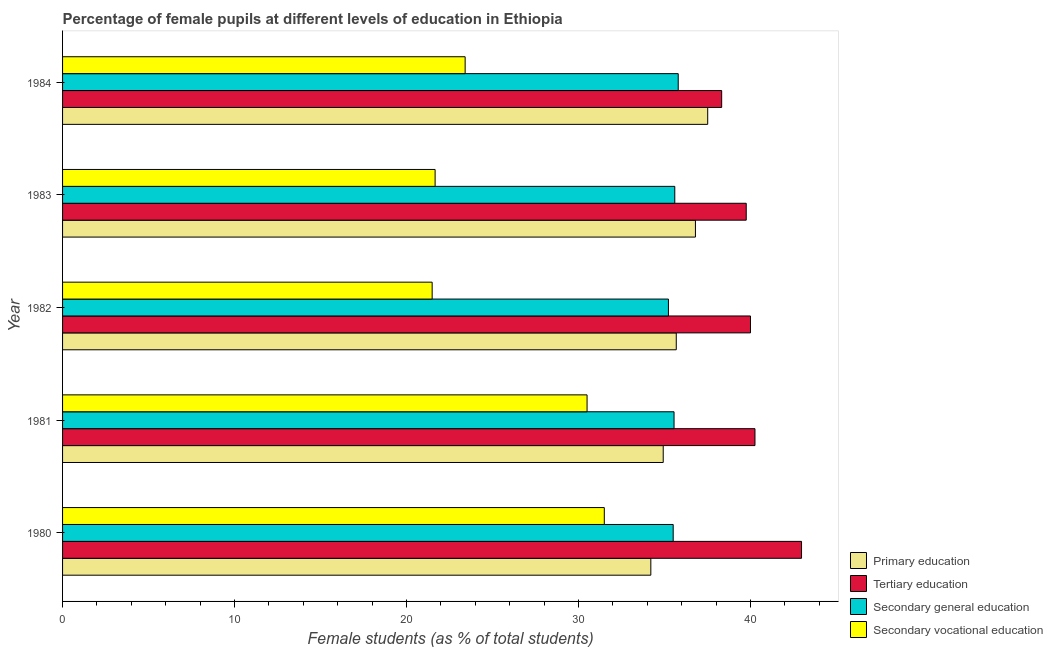How many different coloured bars are there?
Keep it short and to the point. 4. How many groups of bars are there?
Give a very brief answer. 5. Are the number of bars on each tick of the Y-axis equal?
Ensure brevity in your answer.  Yes. How many bars are there on the 5th tick from the top?
Offer a terse response. 4. In how many cases, is the number of bars for a given year not equal to the number of legend labels?
Give a very brief answer. 0. What is the percentage of female students in tertiary education in 1983?
Provide a short and direct response. 39.75. Across all years, what is the maximum percentage of female students in tertiary education?
Give a very brief answer. 42.96. Across all years, what is the minimum percentage of female students in secondary education?
Ensure brevity in your answer.  35.22. In which year was the percentage of female students in secondary vocational education maximum?
Keep it short and to the point. 1980. What is the total percentage of female students in secondary vocational education in the graph?
Offer a terse response. 128.54. What is the difference between the percentage of female students in secondary vocational education in 1982 and that in 1983?
Provide a short and direct response. -0.17. What is the difference between the percentage of female students in primary education in 1982 and the percentage of female students in secondary education in 1980?
Make the answer very short. 0.18. What is the average percentage of female students in primary education per year?
Keep it short and to the point. 35.82. In the year 1984, what is the difference between the percentage of female students in primary education and percentage of female students in tertiary education?
Make the answer very short. -0.81. In how many years, is the percentage of female students in secondary vocational education greater than 32 %?
Your answer should be very brief. 0. What is the ratio of the percentage of female students in tertiary education in 1982 to that in 1984?
Give a very brief answer. 1.04. Is the percentage of female students in tertiary education in 1981 less than that in 1982?
Your response must be concise. No. Is the difference between the percentage of female students in secondary education in 1982 and 1983 greater than the difference between the percentage of female students in tertiary education in 1982 and 1983?
Your answer should be compact. No. What is the difference between the highest and the lowest percentage of female students in secondary education?
Your response must be concise. 0.57. In how many years, is the percentage of female students in secondary education greater than the average percentage of female students in secondary education taken over all years?
Your answer should be very brief. 3. Is it the case that in every year, the sum of the percentage of female students in primary education and percentage of female students in secondary education is greater than the sum of percentage of female students in tertiary education and percentage of female students in secondary vocational education?
Ensure brevity in your answer.  No. What does the 3rd bar from the top in 1984 represents?
Your response must be concise. Tertiary education. Is it the case that in every year, the sum of the percentage of female students in primary education and percentage of female students in tertiary education is greater than the percentage of female students in secondary education?
Your response must be concise. Yes. How many bars are there?
Offer a terse response. 20. What is the difference between two consecutive major ticks on the X-axis?
Offer a very short reply. 10. Are the values on the major ticks of X-axis written in scientific E-notation?
Offer a very short reply. No. Where does the legend appear in the graph?
Your response must be concise. Bottom right. How many legend labels are there?
Your answer should be compact. 4. What is the title of the graph?
Give a very brief answer. Percentage of female pupils at different levels of education in Ethiopia. Does "United Kingdom" appear as one of the legend labels in the graph?
Provide a short and direct response. No. What is the label or title of the X-axis?
Your answer should be very brief. Female students (as % of total students). What is the Female students (as % of total students) in Primary education in 1980?
Keep it short and to the point. 34.2. What is the Female students (as % of total students) in Tertiary education in 1980?
Provide a succinct answer. 42.96. What is the Female students (as % of total students) of Secondary general education in 1980?
Make the answer very short. 35.5. What is the Female students (as % of total students) in Secondary vocational education in 1980?
Provide a short and direct response. 31.5. What is the Female students (as % of total students) in Primary education in 1981?
Provide a succinct answer. 34.92. What is the Female students (as % of total students) of Tertiary education in 1981?
Give a very brief answer. 40.25. What is the Female students (as % of total students) of Secondary general education in 1981?
Your answer should be compact. 35.55. What is the Female students (as % of total students) in Secondary vocational education in 1981?
Make the answer very short. 30.49. What is the Female students (as % of total students) in Primary education in 1982?
Provide a succinct answer. 35.68. What is the Female students (as % of total students) of Tertiary education in 1982?
Your answer should be compact. 40. What is the Female students (as % of total students) of Secondary general education in 1982?
Your response must be concise. 35.22. What is the Female students (as % of total students) in Secondary vocational education in 1982?
Your response must be concise. 21.49. What is the Female students (as % of total students) in Primary education in 1983?
Your answer should be compact. 36.79. What is the Female students (as % of total students) of Tertiary education in 1983?
Make the answer very short. 39.75. What is the Female students (as % of total students) of Secondary general education in 1983?
Make the answer very short. 35.59. What is the Female students (as % of total students) of Secondary vocational education in 1983?
Make the answer very short. 21.66. What is the Female students (as % of total students) of Primary education in 1984?
Your response must be concise. 37.51. What is the Female students (as % of total students) of Tertiary education in 1984?
Keep it short and to the point. 38.32. What is the Female students (as % of total students) of Secondary general education in 1984?
Your answer should be very brief. 35.79. What is the Female students (as % of total students) of Secondary vocational education in 1984?
Keep it short and to the point. 23.41. Across all years, what is the maximum Female students (as % of total students) of Primary education?
Your answer should be very brief. 37.51. Across all years, what is the maximum Female students (as % of total students) of Tertiary education?
Keep it short and to the point. 42.96. Across all years, what is the maximum Female students (as % of total students) in Secondary general education?
Offer a terse response. 35.79. Across all years, what is the maximum Female students (as % of total students) of Secondary vocational education?
Offer a terse response. 31.5. Across all years, what is the minimum Female students (as % of total students) in Primary education?
Make the answer very short. 34.2. Across all years, what is the minimum Female students (as % of total students) in Tertiary education?
Your answer should be very brief. 38.32. Across all years, what is the minimum Female students (as % of total students) of Secondary general education?
Ensure brevity in your answer.  35.22. Across all years, what is the minimum Female students (as % of total students) of Secondary vocational education?
Provide a succinct answer. 21.49. What is the total Female students (as % of total students) in Primary education in the graph?
Provide a succinct answer. 179.1. What is the total Female students (as % of total students) in Tertiary education in the graph?
Provide a succinct answer. 201.28. What is the total Female students (as % of total students) in Secondary general education in the graph?
Offer a terse response. 177.66. What is the total Female students (as % of total students) in Secondary vocational education in the graph?
Offer a very short reply. 128.54. What is the difference between the Female students (as % of total students) in Primary education in 1980 and that in 1981?
Provide a short and direct response. -0.72. What is the difference between the Female students (as % of total students) of Tertiary education in 1980 and that in 1981?
Give a very brief answer. 2.71. What is the difference between the Female students (as % of total students) of Secondary general education in 1980 and that in 1981?
Provide a short and direct response. -0.05. What is the difference between the Female students (as % of total students) in Primary education in 1980 and that in 1982?
Offer a very short reply. -1.48. What is the difference between the Female students (as % of total students) in Tertiary education in 1980 and that in 1982?
Offer a very short reply. 2.97. What is the difference between the Female students (as % of total students) in Secondary general education in 1980 and that in 1982?
Your answer should be compact. 0.28. What is the difference between the Female students (as % of total students) in Secondary vocational education in 1980 and that in 1982?
Keep it short and to the point. 10.01. What is the difference between the Female students (as % of total students) of Primary education in 1980 and that in 1983?
Ensure brevity in your answer.  -2.59. What is the difference between the Female students (as % of total students) of Tertiary education in 1980 and that in 1983?
Your response must be concise. 3.21. What is the difference between the Female students (as % of total students) in Secondary general education in 1980 and that in 1983?
Offer a terse response. -0.09. What is the difference between the Female students (as % of total students) in Secondary vocational education in 1980 and that in 1983?
Provide a short and direct response. 9.84. What is the difference between the Female students (as % of total students) of Primary education in 1980 and that in 1984?
Your response must be concise. -3.31. What is the difference between the Female students (as % of total students) in Tertiary education in 1980 and that in 1984?
Your answer should be very brief. 4.64. What is the difference between the Female students (as % of total students) of Secondary general education in 1980 and that in 1984?
Make the answer very short. -0.29. What is the difference between the Female students (as % of total students) in Secondary vocational education in 1980 and that in 1984?
Ensure brevity in your answer.  8.09. What is the difference between the Female students (as % of total students) in Primary education in 1981 and that in 1982?
Keep it short and to the point. -0.76. What is the difference between the Female students (as % of total students) of Tertiary education in 1981 and that in 1982?
Your answer should be compact. 0.26. What is the difference between the Female students (as % of total students) in Secondary general education in 1981 and that in 1982?
Make the answer very short. 0.33. What is the difference between the Female students (as % of total students) in Secondary vocational education in 1981 and that in 1982?
Keep it short and to the point. 9.01. What is the difference between the Female students (as % of total students) of Primary education in 1981 and that in 1983?
Give a very brief answer. -1.87. What is the difference between the Female students (as % of total students) of Tertiary education in 1981 and that in 1983?
Give a very brief answer. 0.51. What is the difference between the Female students (as % of total students) of Secondary general education in 1981 and that in 1983?
Ensure brevity in your answer.  -0.04. What is the difference between the Female students (as % of total students) of Secondary vocational education in 1981 and that in 1983?
Offer a very short reply. 8.83. What is the difference between the Female students (as % of total students) in Primary education in 1981 and that in 1984?
Keep it short and to the point. -2.59. What is the difference between the Female students (as % of total students) in Tertiary education in 1981 and that in 1984?
Keep it short and to the point. 1.94. What is the difference between the Female students (as % of total students) of Secondary general education in 1981 and that in 1984?
Offer a very short reply. -0.24. What is the difference between the Female students (as % of total students) in Secondary vocational education in 1981 and that in 1984?
Your answer should be compact. 7.09. What is the difference between the Female students (as % of total students) of Primary education in 1982 and that in 1983?
Offer a very short reply. -1.11. What is the difference between the Female students (as % of total students) of Tertiary education in 1982 and that in 1983?
Ensure brevity in your answer.  0.25. What is the difference between the Female students (as % of total students) in Secondary general education in 1982 and that in 1983?
Offer a very short reply. -0.37. What is the difference between the Female students (as % of total students) in Secondary vocational education in 1982 and that in 1983?
Keep it short and to the point. -0.17. What is the difference between the Female students (as % of total students) of Primary education in 1982 and that in 1984?
Offer a very short reply. -1.83. What is the difference between the Female students (as % of total students) in Tertiary education in 1982 and that in 1984?
Keep it short and to the point. 1.68. What is the difference between the Female students (as % of total students) in Secondary general education in 1982 and that in 1984?
Offer a very short reply. -0.57. What is the difference between the Female students (as % of total students) of Secondary vocational education in 1982 and that in 1984?
Provide a succinct answer. -1.92. What is the difference between the Female students (as % of total students) of Primary education in 1983 and that in 1984?
Provide a succinct answer. -0.71. What is the difference between the Female students (as % of total students) in Tertiary education in 1983 and that in 1984?
Offer a very short reply. 1.43. What is the difference between the Female students (as % of total students) in Secondary general education in 1983 and that in 1984?
Give a very brief answer. -0.2. What is the difference between the Female students (as % of total students) of Secondary vocational education in 1983 and that in 1984?
Provide a succinct answer. -1.75. What is the difference between the Female students (as % of total students) of Primary education in 1980 and the Female students (as % of total students) of Tertiary education in 1981?
Your answer should be compact. -6.05. What is the difference between the Female students (as % of total students) of Primary education in 1980 and the Female students (as % of total students) of Secondary general education in 1981?
Your answer should be compact. -1.35. What is the difference between the Female students (as % of total students) of Primary education in 1980 and the Female students (as % of total students) of Secondary vocational education in 1981?
Give a very brief answer. 3.71. What is the difference between the Female students (as % of total students) in Tertiary education in 1980 and the Female students (as % of total students) in Secondary general education in 1981?
Your response must be concise. 7.41. What is the difference between the Female students (as % of total students) in Tertiary education in 1980 and the Female students (as % of total students) in Secondary vocational education in 1981?
Your answer should be very brief. 12.47. What is the difference between the Female students (as % of total students) in Secondary general education in 1980 and the Female students (as % of total students) in Secondary vocational education in 1981?
Your response must be concise. 5.01. What is the difference between the Female students (as % of total students) in Primary education in 1980 and the Female students (as % of total students) in Tertiary education in 1982?
Ensure brevity in your answer.  -5.8. What is the difference between the Female students (as % of total students) in Primary education in 1980 and the Female students (as % of total students) in Secondary general education in 1982?
Give a very brief answer. -1.02. What is the difference between the Female students (as % of total students) in Primary education in 1980 and the Female students (as % of total students) in Secondary vocational education in 1982?
Keep it short and to the point. 12.71. What is the difference between the Female students (as % of total students) of Tertiary education in 1980 and the Female students (as % of total students) of Secondary general education in 1982?
Provide a short and direct response. 7.74. What is the difference between the Female students (as % of total students) in Tertiary education in 1980 and the Female students (as % of total students) in Secondary vocational education in 1982?
Your answer should be compact. 21.47. What is the difference between the Female students (as % of total students) in Secondary general education in 1980 and the Female students (as % of total students) in Secondary vocational education in 1982?
Ensure brevity in your answer.  14.01. What is the difference between the Female students (as % of total students) of Primary education in 1980 and the Female students (as % of total students) of Tertiary education in 1983?
Provide a short and direct response. -5.55. What is the difference between the Female students (as % of total students) in Primary education in 1980 and the Female students (as % of total students) in Secondary general education in 1983?
Make the answer very short. -1.39. What is the difference between the Female students (as % of total students) in Primary education in 1980 and the Female students (as % of total students) in Secondary vocational education in 1983?
Provide a short and direct response. 12.54. What is the difference between the Female students (as % of total students) in Tertiary education in 1980 and the Female students (as % of total students) in Secondary general education in 1983?
Give a very brief answer. 7.37. What is the difference between the Female students (as % of total students) of Tertiary education in 1980 and the Female students (as % of total students) of Secondary vocational education in 1983?
Your answer should be very brief. 21.3. What is the difference between the Female students (as % of total students) in Secondary general education in 1980 and the Female students (as % of total students) in Secondary vocational education in 1983?
Your answer should be compact. 13.84. What is the difference between the Female students (as % of total students) of Primary education in 1980 and the Female students (as % of total students) of Tertiary education in 1984?
Provide a succinct answer. -4.12. What is the difference between the Female students (as % of total students) in Primary education in 1980 and the Female students (as % of total students) in Secondary general education in 1984?
Your response must be concise. -1.59. What is the difference between the Female students (as % of total students) in Primary education in 1980 and the Female students (as % of total students) in Secondary vocational education in 1984?
Make the answer very short. 10.79. What is the difference between the Female students (as % of total students) in Tertiary education in 1980 and the Female students (as % of total students) in Secondary general education in 1984?
Give a very brief answer. 7.17. What is the difference between the Female students (as % of total students) in Tertiary education in 1980 and the Female students (as % of total students) in Secondary vocational education in 1984?
Provide a succinct answer. 19.56. What is the difference between the Female students (as % of total students) of Secondary general education in 1980 and the Female students (as % of total students) of Secondary vocational education in 1984?
Your answer should be compact. 12.1. What is the difference between the Female students (as % of total students) in Primary education in 1981 and the Female students (as % of total students) in Tertiary education in 1982?
Make the answer very short. -5.07. What is the difference between the Female students (as % of total students) of Primary education in 1981 and the Female students (as % of total students) of Secondary general education in 1982?
Provide a short and direct response. -0.3. What is the difference between the Female students (as % of total students) in Primary education in 1981 and the Female students (as % of total students) in Secondary vocational education in 1982?
Offer a terse response. 13.43. What is the difference between the Female students (as % of total students) of Tertiary education in 1981 and the Female students (as % of total students) of Secondary general education in 1982?
Your answer should be compact. 5.03. What is the difference between the Female students (as % of total students) in Tertiary education in 1981 and the Female students (as % of total students) in Secondary vocational education in 1982?
Keep it short and to the point. 18.77. What is the difference between the Female students (as % of total students) in Secondary general education in 1981 and the Female students (as % of total students) in Secondary vocational education in 1982?
Provide a succinct answer. 14.06. What is the difference between the Female students (as % of total students) of Primary education in 1981 and the Female students (as % of total students) of Tertiary education in 1983?
Give a very brief answer. -4.83. What is the difference between the Female students (as % of total students) of Primary education in 1981 and the Female students (as % of total students) of Secondary general education in 1983?
Your answer should be very brief. -0.67. What is the difference between the Female students (as % of total students) of Primary education in 1981 and the Female students (as % of total students) of Secondary vocational education in 1983?
Your response must be concise. 13.26. What is the difference between the Female students (as % of total students) of Tertiary education in 1981 and the Female students (as % of total students) of Secondary general education in 1983?
Your response must be concise. 4.66. What is the difference between the Female students (as % of total students) in Tertiary education in 1981 and the Female students (as % of total students) in Secondary vocational education in 1983?
Provide a succinct answer. 18.6. What is the difference between the Female students (as % of total students) in Secondary general education in 1981 and the Female students (as % of total students) in Secondary vocational education in 1983?
Keep it short and to the point. 13.89. What is the difference between the Female students (as % of total students) in Primary education in 1981 and the Female students (as % of total students) in Tertiary education in 1984?
Provide a short and direct response. -3.4. What is the difference between the Female students (as % of total students) in Primary education in 1981 and the Female students (as % of total students) in Secondary general education in 1984?
Your answer should be very brief. -0.87. What is the difference between the Female students (as % of total students) of Primary education in 1981 and the Female students (as % of total students) of Secondary vocational education in 1984?
Your answer should be very brief. 11.52. What is the difference between the Female students (as % of total students) of Tertiary education in 1981 and the Female students (as % of total students) of Secondary general education in 1984?
Your response must be concise. 4.46. What is the difference between the Female students (as % of total students) of Tertiary education in 1981 and the Female students (as % of total students) of Secondary vocational education in 1984?
Your answer should be compact. 16.85. What is the difference between the Female students (as % of total students) of Secondary general education in 1981 and the Female students (as % of total students) of Secondary vocational education in 1984?
Your response must be concise. 12.14. What is the difference between the Female students (as % of total students) in Primary education in 1982 and the Female students (as % of total students) in Tertiary education in 1983?
Make the answer very short. -4.07. What is the difference between the Female students (as % of total students) in Primary education in 1982 and the Female students (as % of total students) in Secondary general education in 1983?
Offer a terse response. 0.09. What is the difference between the Female students (as % of total students) in Primary education in 1982 and the Female students (as % of total students) in Secondary vocational education in 1983?
Offer a terse response. 14.02. What is the difference between the Female students (as % of total students) in Tertiary education in 1982 and the Female students (as % of total students) in Secondary general education in 1983?
Your answer should be compact. 4.4. What is the difference between the Female students (as % of total students) in Tertiary education in 1982 and the Female students (as % of total students) in Secondary vocational education in 1983?
Provide a short and direct response. 18.34. What is the difference between the Female students (as % of total students) in Secondary general education in 1982 and the Female students (as % of total students) in Secondary vocational education in 1983?
Keep it short and to the point. 13.57. What is the difference between the Female students (as % of total students) of Primary education in 1982 and the Female students (as % of total students) of Tertiary education in 1984?
Offer a terse response. -2.64. What is the difference between the Female students (as % of total students) of Primary education in 1982 and the Female students (as % of total students) of Secondary general education in 1984?
Your response must be concise. -0.11. What is the difference between the Female students (as % of total students) in Primary education in 1982 and the Female students (as % of total students) in Secondary vocational education in 1984?
Ensure brevity in your answer.  12.27. What is the difference between the Female students (as % of total students) in Tertiary education in 1982 and the Female students (as % of total students) in Secondary general education in 1984?
Your response must be concise. 4.2. What is the difference between the Female students (as % of total students) of Tertiary education in 1982 and the Female students (as % of total students) of Secondary vocational education in 1984?
Provide a short and direct response. 16.59. What is the difference between the Female students (as % of total students) of Secondary general education in 1982 and the Female students (as % of total students) of Secondary vocational education in 1984?
Ensure brevity in your answer.  11.82. What is the difference between the Female students (as % of total students) of Primary education in 1983 and the Female students (as % of total students) of Tertiary education in 1984?
Keep it short and to the point. -1.53. What is the difference between the Female students (as % of total students) of Primary education in 1983 and the Female students (as % of total students) of Secondary general education in 1984?
Provide a succinct answer. 1. What is the difference between the Female students (as % of total students) in Primary education in 1983 and the Female students (as % of total students) in Secondary vocational education in 1984?
Keep it short and to the point. 13.39. What is the difference between the Female students (as % of total students) in Tertiary education in 1983 and the Female students (as % of total students) in Secondary general education in 1984?
Your answer should be very brief. 3.95. What is the difference between the Female students (as % of total students) of Tertiary education in 1983 and the Female students (as % of total students) of Secondary vocational education in 1984?
Make the answer very short. 16.34. What is the difference between the Female students (as % of total students) in Secondary general education in 1983 and the Female students (as % of total students) in Secondary vocational education in 1984?
Provide a succinct answer. 12.19. What is the average Female students (as % of total students) of Primary education per year?
Ensure brevity in your answer.  35.82. What is the average Female students (as % of total students) in Tertiary education per year?
Make the answer very short. 40.26. What is the average Female students (as % of total students) in Secondary general education per year?
Make the answer very short. 35.53. What is the average Female students (as % of total students) in Secondary vocational education per year?
Provide a succinct answer. 25.71. In the year 1980, what is the difference between the Female students (as % of total students) in Primary education and Female students (as % of total students) in Tertiary education?
Provide a succinct answer. -8.76. In the year 1980, what is the difference between the Female students (as % of total students) in Primary education and Female students (as % of total students) in Secondary general education?
Your answer should be very brief. -1.3. In the year 1980, what is the difference between the Female students (as % of total students) in Primary education and Female students (as % of total students) in Secondary vocational education?
Provide a succinct answer. 2.71. In the year 1980, what is the difference between the Female students (as % of total students) in Tertiary education and Female students (as % of total students) in Secondary general education?
Your answer should be compact. 7.46. In the year 1980, what is the difference between the Female students (as % of total students) of Tertiary education and Female students (as % of total students) of Secondary vocational education?
Provide a short and direct response. 11.47. In the year 1980, what is the difference between the Female students (as % of total students) of Secondary general education and Female students (as % of total students) of Secondary vocational education?
Give a very brief answer. 4.01. In the year 1981, what is the difference between the Female students (as % of total students) of Primary education and Female students (as % of total students) of Tertiary education?
Provide a short and direct response. -5.33. In the year 1981, what is the difference between the Female students (as % of total students) in Primary education and Female students (as % of total students) in Secondary general education?
Your response must be concise. -0.63. In the year 1981, what is the difference between the Female students (as % of total students) in Primary education and Female students (as % of total students) in Secondary vocational education?
Provide a short and direct response. 4.43. In the year 1981, what is the difference between the Female students (as % of total students) of Tertiary education and Female students (as % of total students) of Secondary general education?
Provide a short and direct response. 4.7. In the year 1981, what is the difference between the Female students (as % of total students) in Tertiary education and Female students (as % of total students) in Secondary vocational education?
Offer a terse response. 9.76. In the year 1981, what is the difference between the Female students (as % of total students) in Secondary general education and Female students (as % of total students) in Secondary vocational education?
Provide a short and direct response. 5.06. In the year 1982, what is the difference between the Female students (as % of total students) of Primary education and Female students (as % of total students) of Tertiary education?
Offer a very short reply. -4.32. In the year 1982, what is the difference between the Female students (as % of total students) of Primary education and Female students (as % of total students) of Secondary general education?
Your answer should be compact. 0.45. In the year 1982, what is the difference between the Female students (as % of total students) of Primary education and Female students (as % of total students) of Secondary vocational education?
Offer a very short reply. 14.19. In the year 1982, what is the difference between the Female students (as % of total students) of Tertiary education and Female students (as % of total students) of Secondary general education?
Provide a short and direct response. 4.77. In the year 1982, what is the difference between the Female students (as % of total students) in Tertiary education and Female students (as % of total students) in Secondary vocational education?
Ensure brevity in your answer.  18.51. In the year 1982, what is the difference between the Female students (as % of total students) of Secondary general education and Female students (as % of total students) of Secondary vocational education?
Your response must be concise. 13.74. In the year 1983, what is the difference between the Female students (as % of total students) in Primary education and Female students (as % of total students) in Tertiary education?
Offer a very short reply. -2.95. In the year 1983, what is the difference between the Female students (as % of total students) in Primary education and Female students (as % of total students) in Secondary general education?
Make the answer very short. 1.2. In the year 1983, what is the difference between the Female students (as % of total students) in Primary education and Female students (as % of total students) in Secondary vocational education?
Give a very brief answer. 15.13. In the year 1983, what is the difference between the Female students (as % of total students) in Tertiary education and Female students (as % of total students) in Secondary general education?
Offer a very short reply. 4.15. In the year 1983, what is the difference between the Female students (as % of total students) of Tertiary education and Female students (as % of total students) of Secondary vocational education?
Offer a terse response. 18.09. In the year 1983, what is the difference between the Female students (as % of total students) of Secondary general education and Female students (as % of total students) of Secondary vocational education?
Your answer should be very brief. 13.93. In the year 1984, what is the difference between the Female students (as % of total students) in Primary education and Female students (as % of total students) in Tertiary education?
Provide a succinct answer. -0.81. In the year 1984, what is the difference between the Female students (as % of total students) of Primary education and Female students (as % of total students) of Secondary general education?
Offer a terse response. 1.71. In the year 1984, what is the difference between the Female students (as % of total students) in Primary education and Female students (as % of total students) in Secondary vocational education?
Make the answer very short. 14.1. In the year 1984, what is the difference between the Female students (as % of total students) of Tertiary education and Female students (as % of total students) of Secondary general education?
Offer a terse response. 2.53. In the year 1984, what is the difference between the Female students (as % of total students) in Tertiary education and Female students (as % of total students) in Secondary vocational education?
Your answer should be compact. 14.91. In the year 1984, what is the difference between the Female students (as % of total students) in Secondary general education and Female students (as % of total students) in Secondary vocational education?
Provide a succinct answer. 12.39. What is the ratio of the Female students (as % of total students) in Primary education in 1980 to that in 1981?
Keep it short and to the point. 0.98. What is the ratio of the Female students (as % of total students) in Tertiary education in 1980 to that in 1981?
Your answer should be very brief. 1.07. What is the ratio of the Female students (as % of total students) of Secondary vocational education in 1980 to that in 1981?
Ensure brevity in your answer.  1.03. What is the ratio of the Female students (as % of total students) of Primary education in 1980 to that in 1982?
Offer a terse response. 0.96. What is the ratio of the Female students (as % of total students) in Tertiary education in 1980 to that in 1982?
Your response must be concise. 1.07. What is the ratio of the Female students (as % of total students) in Secondary general education in 1980 to that in 1982?
Your response must be concise. 1.01. What is the ratio of the Female students (as % of total students) of Secondary vocational education in 1980 to that in 1982?
Your answer should be compact. 1.47. What is the ratio of the Female students (as % of total students) in Primary education in 1980 to that in 1983?
Your response must be concise. 0.93. What is the ratio of the Female students (as % of total students) in Tertiary education in 1980 to that in 1983?
Your answer should be very brief. 1.08. What is the ratio of the Female students (as % of total students) of Secondary vocational education in 1980 to that in 1983?
Your response must be concise. 1.45. What is the ratio of the Female students (as % of total students) of Primary education in 1980 to that in 1984?
Provide a short and direct response. 0.91. What is the ratio of the Female students (as % of total students) of Tertiary education in 1980 to that in 1984?
Provide a short and direct response. 1.12. What is the ratio of the Female students (as % of total students) in Secondary general education in 1980 to that in 1984?
Keep it short and to the point. 0.99. What is the ratio of the Female students (as % of total students) in Secondary vocational education in 1980 to that in 1984?
Keep it short and to the point. 1.35. What is the ratio of the Female students (as % of total students) in Primary education in 1981 to that in 1982?
Make the answer very short. 0.98. What is the ratio of the Female students (as % of total students) of Secondary general education in 1981 to that in 1982?
Offer a very short reply. 1.01. What is the ratio of the Female students (as % of total students) of Secondary vocational education in 1981 to that in 1982?
Keep it short and to the point. 1.42. What is the ratio of the Female students (as % of total students) of Primary education in 1981 to that in 1983?
Provide a short and direct response. 0.95. What is the ratio of the Female students (as % of total students) in Tertiary education in 1981 to that in 1983?
Give a very brief answer. 1.01. What is the ratio of the Female students (as % of total students) in Secondary general education in 1981 to that in 1983?
Offer a terse response. 1. What is the ratio of the Female students (as % of total students) of Secondary vocational education in 1981 to that in 1983?
Ensure brevity in your answer.  1.41. What is the ratio of the Female students (as % of total students) of Primary education in 1981 to that in 1984?
Your response must be concise. 0.93. What is the ratio of the Female students (as % of total students) in Tertiary education in 1981 to that in 1984?
Provide a short and direct response. 1.05. What is the ratio of the Female students (as % of total students) of Secondary vocational education in 1981 to that in 1984?
Provide a succinct answer. 1.3. What is the ratio of the Female students (as % of total students) of Primary education in 1982 to that in 1983?
Your response must be concise. 0.97. What is the ratio of the Female students (as % of total students) in Tertiary education in 1982 to that in 1983?
Provide a succinct answer. 1.01. What is the ratio of the Female students (as % of total students) in Primary education in 1982 to that in 1984?
Make the answer very short. 0.95. What is the ratio of the Female students (as % of total students) in Tertiary education in 1982 to that in 1984?
Offer a terse response. 1.04. What is the ratio of the Female students (as % of total students) in Secondary general education in 1982 to that in 1984?
Your response must be concise. 0.98. What is the ratio of the Female students (as % of total students) of Secondary vocational education in 1982 to that in 1984?
Your answer should be very brief. 0.92. What is the ratio of the Female students (as % of total students) in Tertiary education in 1983 to that in 1984?
Your response must be concise. 1.04. What is the ratio of the Female students (as % of total students) in Secondary vocational education in 1983 to that in 1984?
Keep it short and to the point. 0.93. What is the difference between the highest and the second highest Female students (as % of total students) of Primary education?
Make the answer very short. 0.71. What is the difference between the highest and the second highest Female students (as % of total students) in Tertiary education?
Offer a very short reply. 2.71. What is the difference between the highest and the second highest Female students (as % of total students) in Secondary general education?
Provide a short and direct response. 0.2. What is the difference between the highest and the lowest Female students (as % of total students) of Primary education?
Provide a short and direct response. 3.31. What is the difference between the highest and the lowest Female students (as % of total students) of Tertiary education?
Provide a short and direct response. 4.64. What is the difference between the highest and the lowest Female students (as % of total students) of Secondary general education?
Give a very brief answer. 0.57. What is the difference between the highest and the lowest Female students (as % of total students) of Secondary vocational education?
Keep it short and to the point. 10.01. 